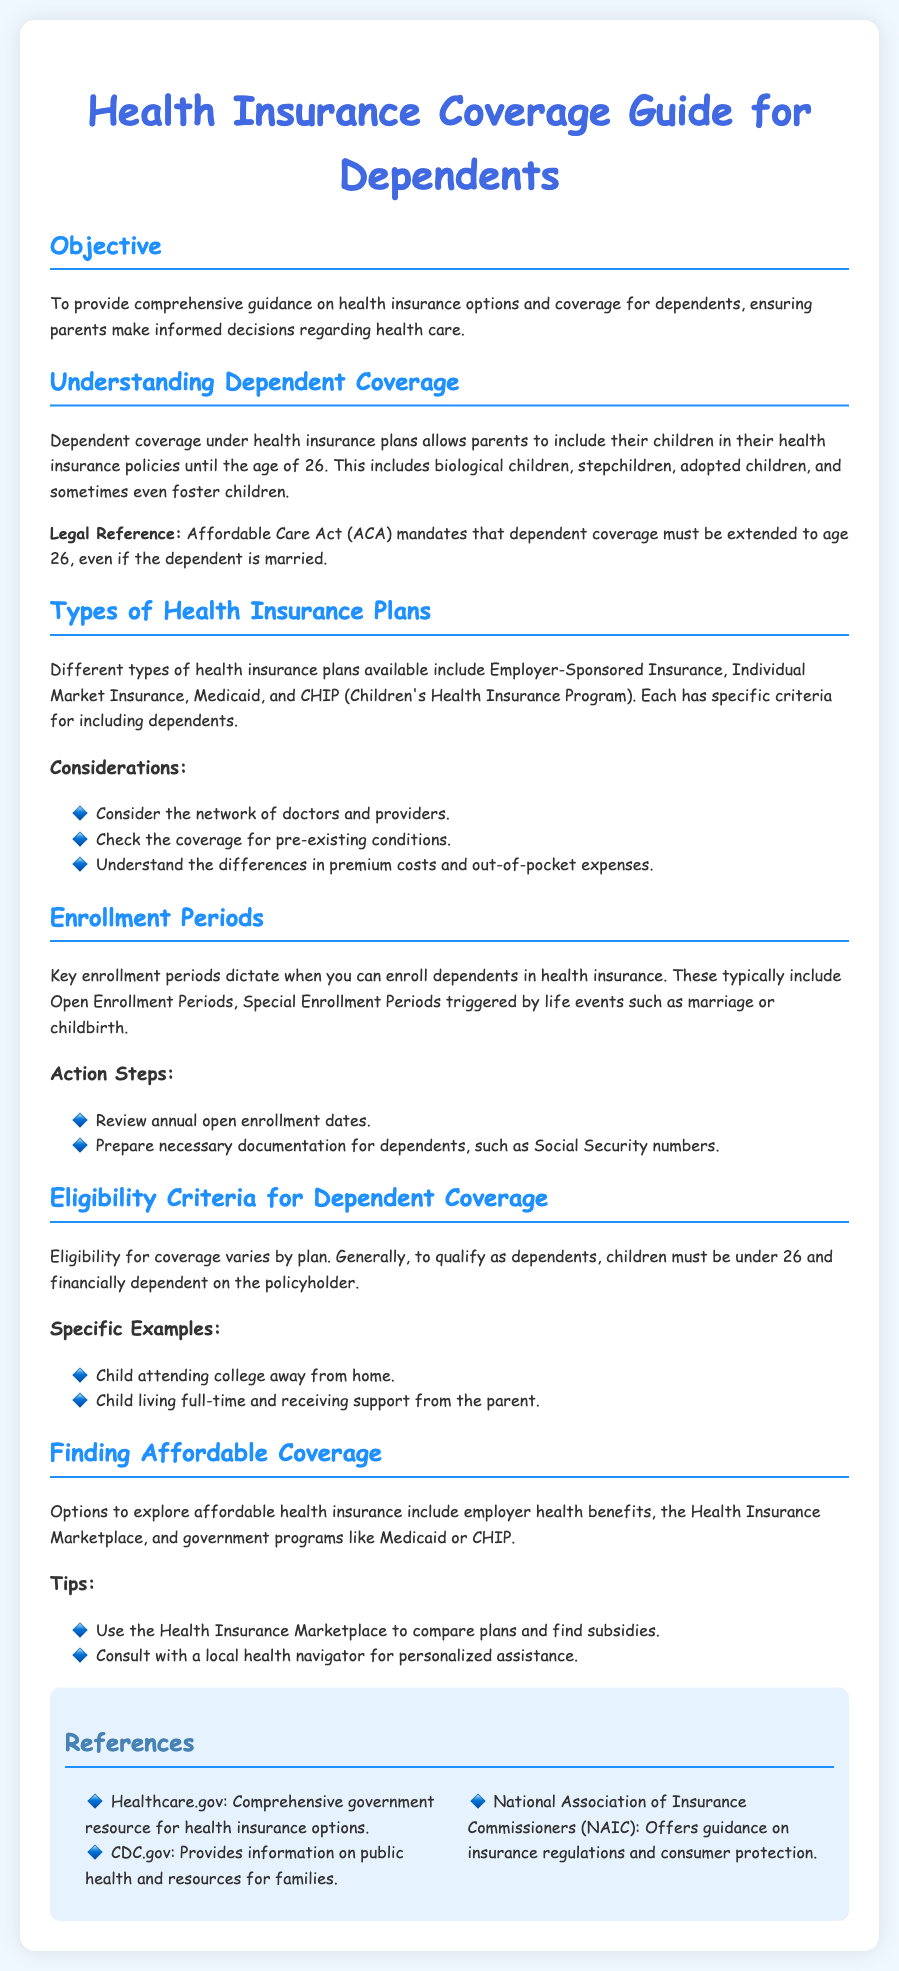What is the objective of the guide? The objective is to provide comprehensive guidance on health insurance options and coverage for dependents.
Answer: comprehensive guidance What is the maximum age for dependents to be covered? The Affordable Care Act mandates that dependent coverage must be extended until age 26.
Answer: 26 What types of health insurance plans are mentioned? The document mentions Employer-Sponsored Insurance, Individual Market Insurance, Medicaid, and CHIP.
Answer: Employer-Sponsored Insurance, Individual Market Insurance, Medicaid, CHIP What key periods dictate enrollment? Key enrollment periods include Open Enrollment Periods and Special Enrollment Periods.
Answer: Open Enrollment Periods, Special Enrollment Periods What is one specific example of a dependent eligibility criterion? A specific example is a child attending college away from home.
Answer: child attending college What option is suggested for finding affordable health insurance? The document suggests using the Health Insurance Marketplace to compare plans.
Answer: Health Insurance Marketplace What family members are included under dependent coverage? Dependent coverage includes biological children, stepchildren, adopted children, and sometimes foster children.
Answer: biological children, stepchildren, adopted children, foster children What should you review during enrollment periods? During enrollment periods, you should review annual open enrollment dates.
Answer: annual open enrollment dates Which resource provides government information on health insurance? Healthcare.gov is a comprehensive government resource for health insurance options.
Answer: Healthcare.gov 